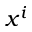Convert formula to latex. <formula><loc_0><loc_0><loc_500><loc_500>x ^ { i }</formula> 